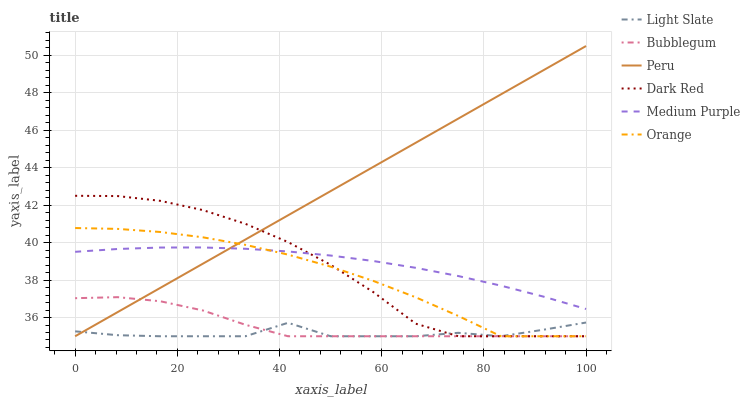Does Light Slate have the minimum area under the curve?
Answer yes or no. Yes. Does Peru have the maximum area under the curve?
Answer yes or no. Yes. Does Dark Red have the minimum area under the curve?
Answer yes or no. No. Does Dark Red have the maximum area under the curve?
Answer yes or no. No. Is Peru the smoothest?
Answer yes or no. Yes. Is Light Slate the roughest?
Answer yes or no. Yes. Is Dark Red the smoothest?
Answer yes or no. No. Is Dark Red the roughest?
Answer yes or no. No. Does Light Slate have the lowest value?
Answer yes or no. Yes. Does Medium Purple have the lowest value?
Answer yes or no. No. Does Peru have the highest value?
Answer yes or no. Yes. Does Dark Red have the highest value?
Answer yes or no. No. Is Light Slate less than Medium Purple?
Answer yes or no. Yes. Is Medium Purple greater than Bubblegum?
Answer yes or no. Yes. Does Light Slate intersect Orange?
Answer yes or no. Yes. Is Light Slate less than Orange?
Answer yes or no. No. Is Light Slate greater than Orange?
Answer yes or no. No. Does Light Slate intersect Medium Purple?
Answer yes or no. No. 